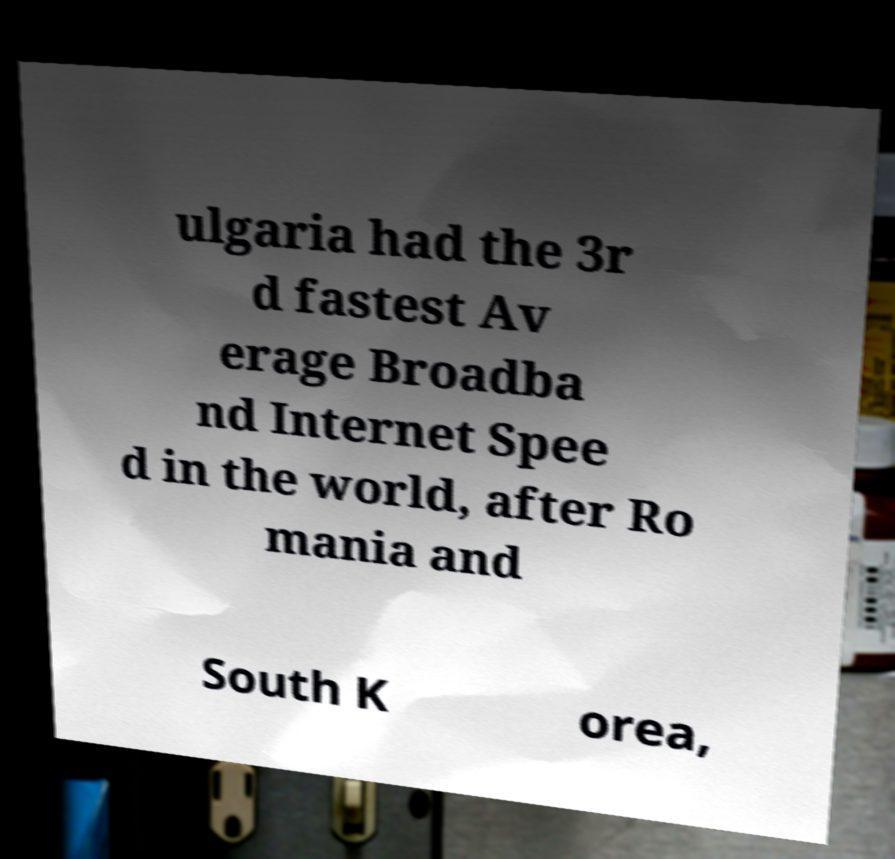Please read and relay the text visible in this image. What does it say? ulgaria had the 3r d fastest Av erage Broadba nd Internet Spee d in the world, after Ro mania and South K orea, 